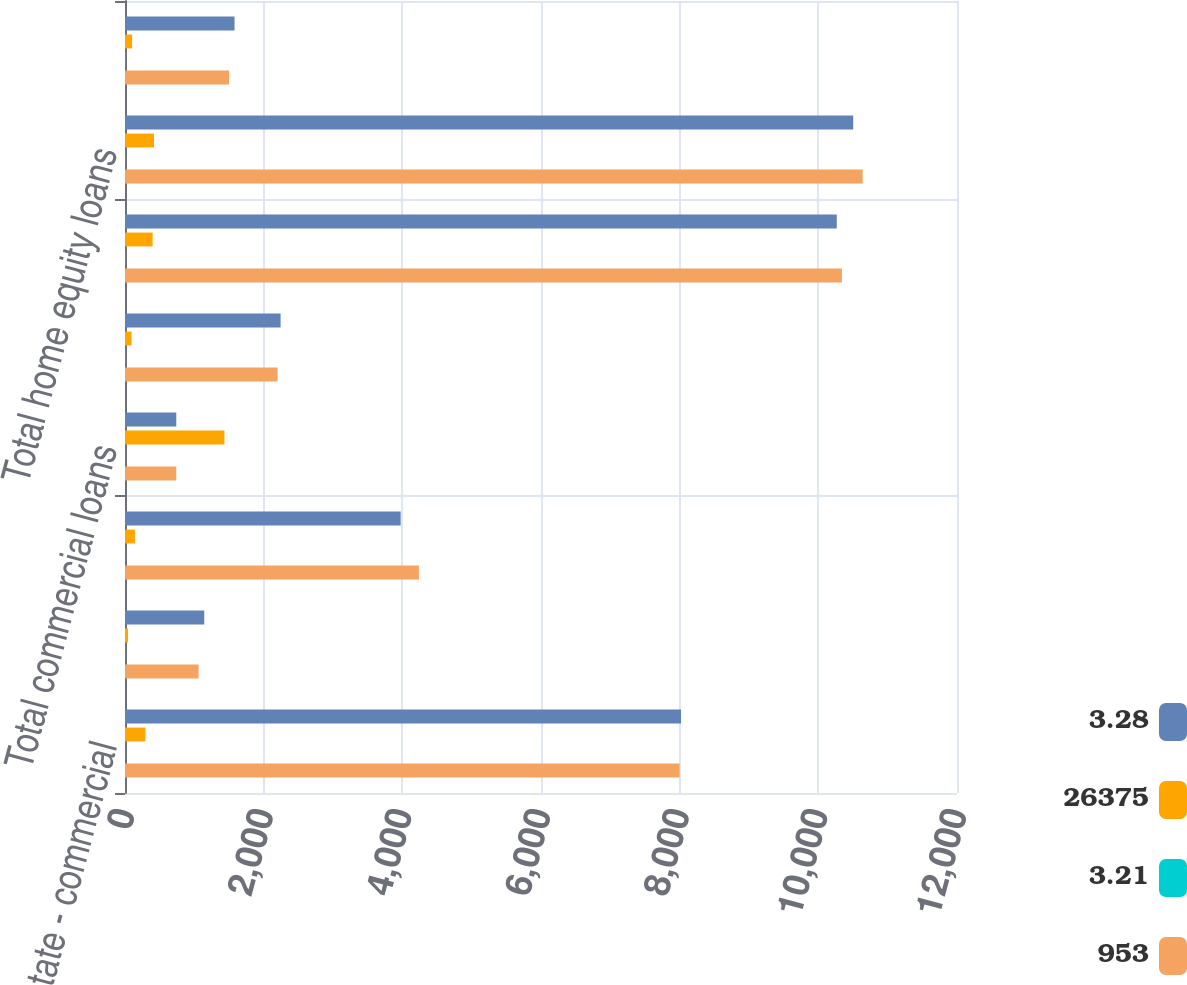<chart> <loc_0><loc_0><loc_500><loc_500><stacked_bar_chart><ecel><fcel>Real estate - commercial<fcel>Real estate - construction<fcel>Commercial lease financing<fcel>Total commercial loans<fcel>Real estate - residential<fcel>Key Community Bank<fcel>Total home equity loans<fcel>Consumer other - Key Community<nl><fcel>3.28<fcel>8020<fcel>1143<fcel>3976<fcel>739.5<fcel>2244<fcel>10266<fcel>10503<fcel>1580<nl><fcel>26375<fcel>295<fcel>43<fcel>143<fcel>1434<fcel>95<fcel>399<fcel>418<fcel>103<nl><fcel>3.21<fcel>3.68<fcel>3.73<fcel>3.6<fcel>3.35<fcel>4.21<fcel>3.89<fcel>3.98<fcel>6.54<nl><fcel>953<fcel>7999<fcel>1061<fcel>4239<fcel>739.5<fcel>2201<fcel>10340<fcel>10639<fcel>1501<nl></chart> 